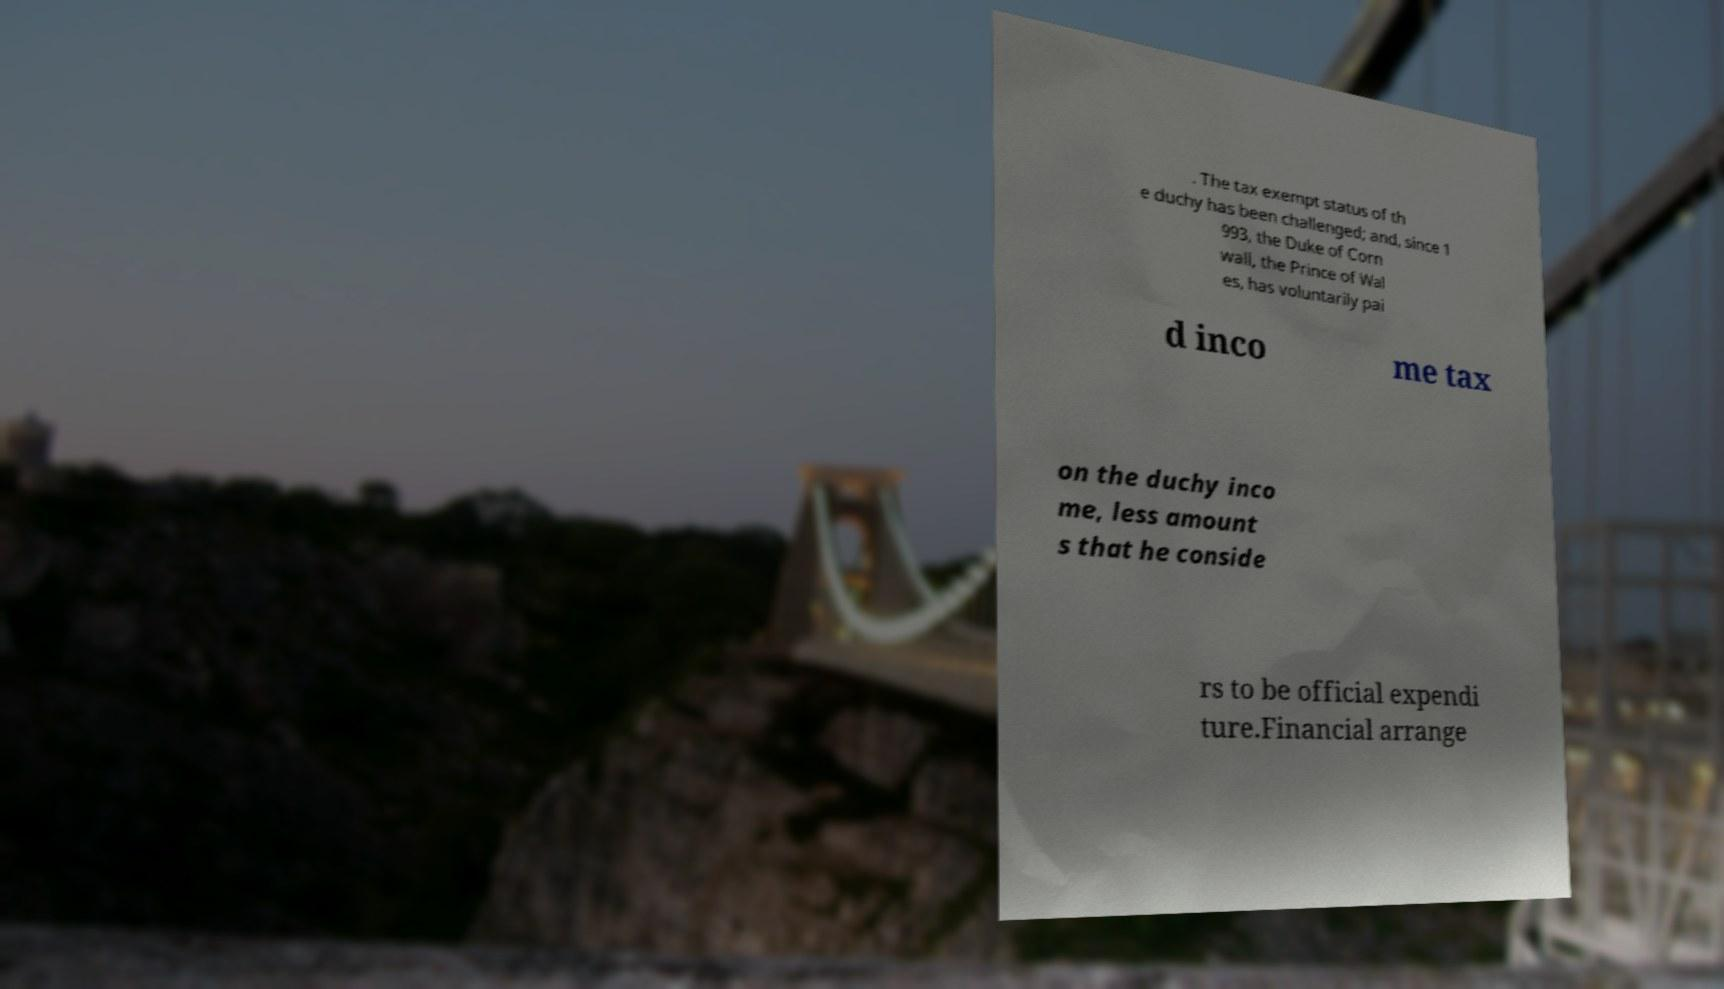Could you assist in decoding the text presented in this image and type it out clearly? . The tax exempt status of th e duchy has been challenged; and, since 1 993, the Duke of Corn wall, the Prince of Wal es, has voluntarily pai d inco me tax on the duchy inco me, less amount s that he conside rs to be official expendi ture.Financial arrange 